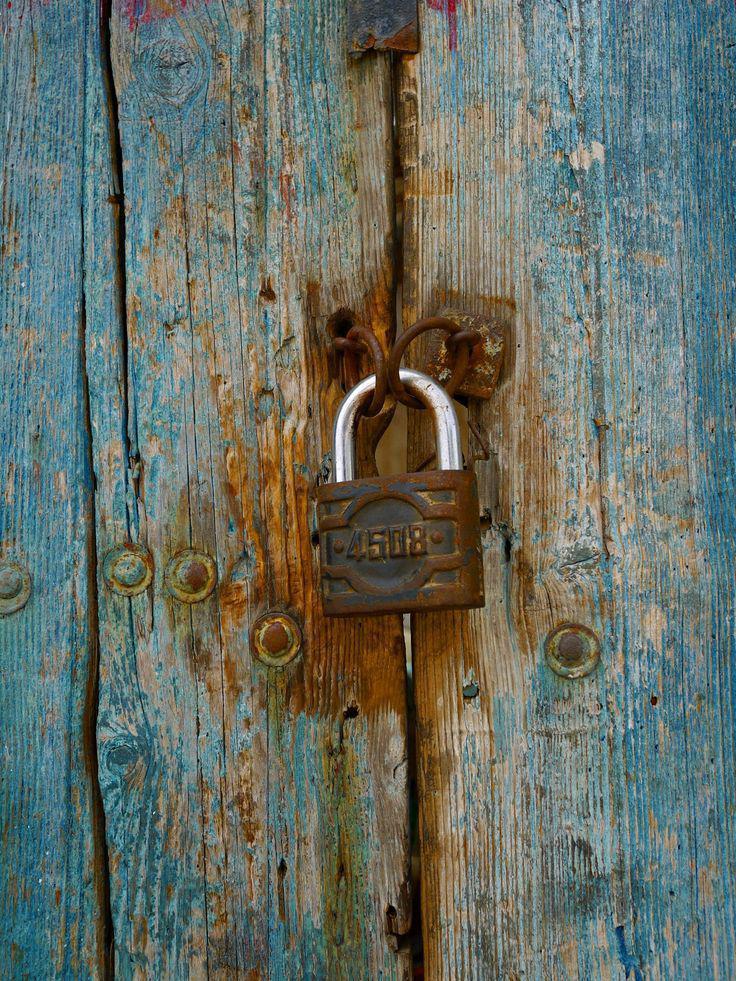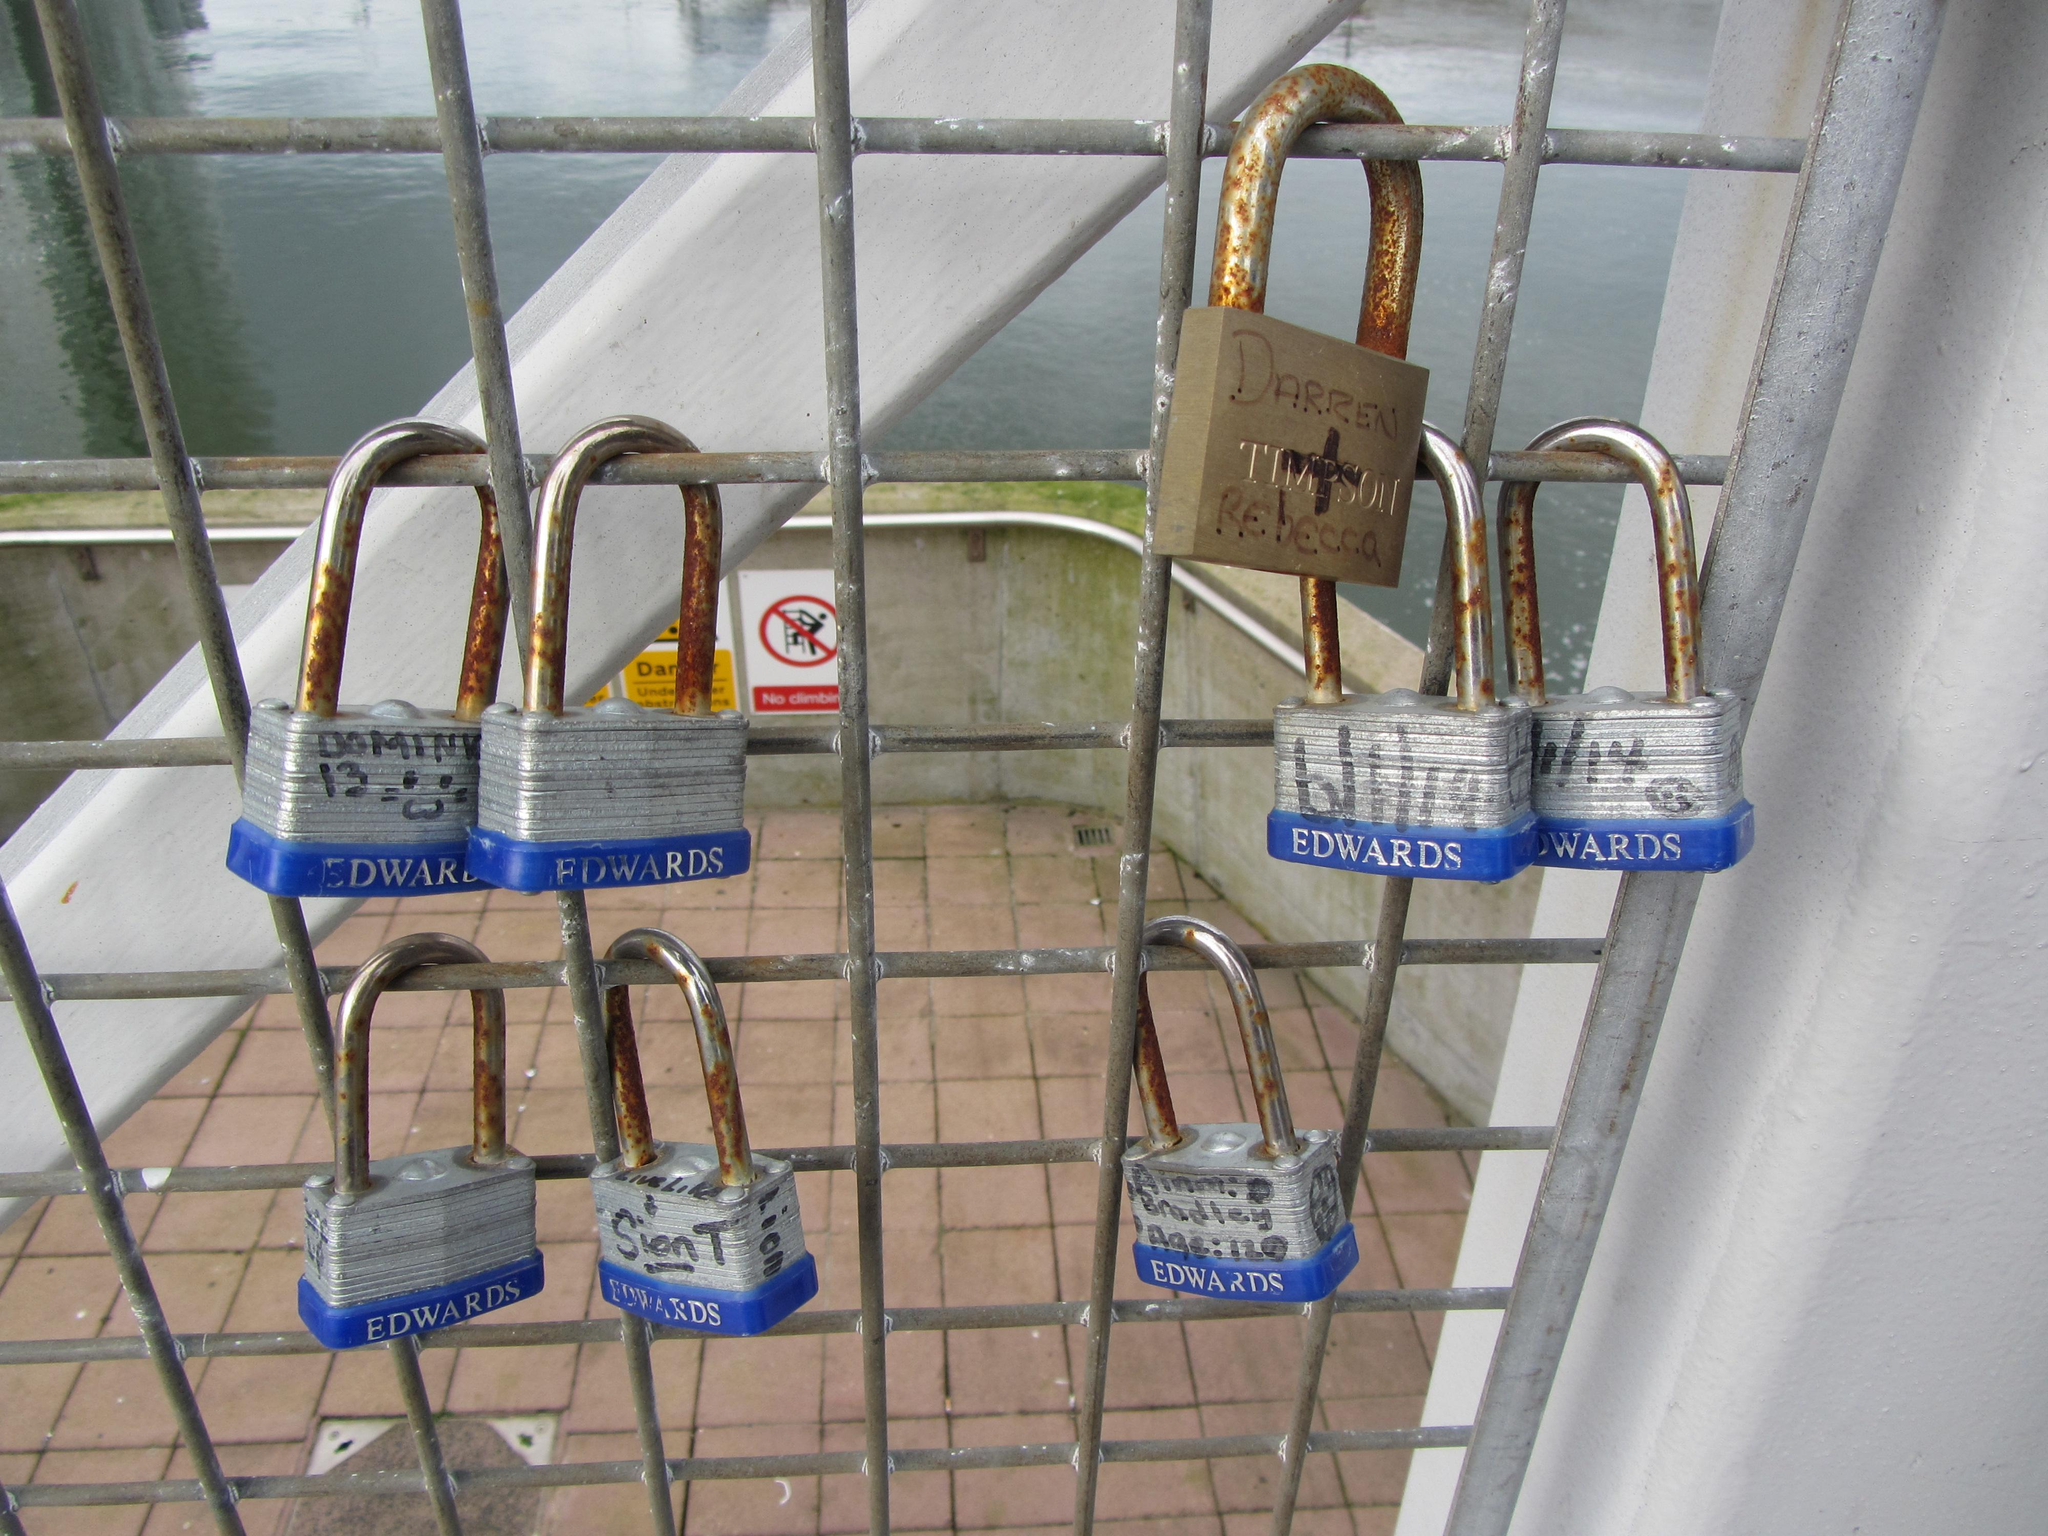The first image is the image on the left, the second image is the image on the right. Analyze the images presented: Is the assertion "There is more than one lock in the right image." valid? Answer yes or no. Yes. The first image is the image on the left, the second image is the image on the right. Evaluate the accuracy of this statement regarding the images: "There is one lock without a key in the right image.". Is it true? Answer yes or no. No. 